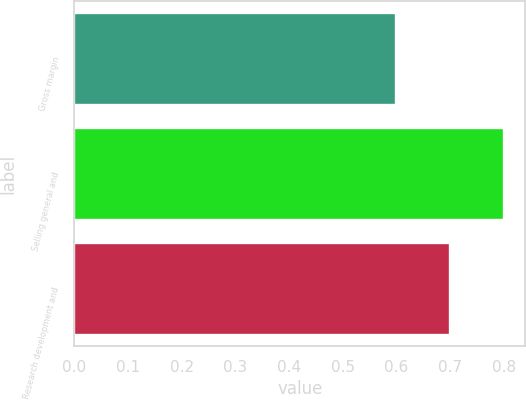Convert chart to OTSL. <chart><loc_0><loc_0><loc_500><loc_500><bar_chart><fcel>Gross margin<fcel>Selling general and<fcel>Research development and<nl><fcel>0.6<fcel>0.8<fcel>0.7<nl></chart> 